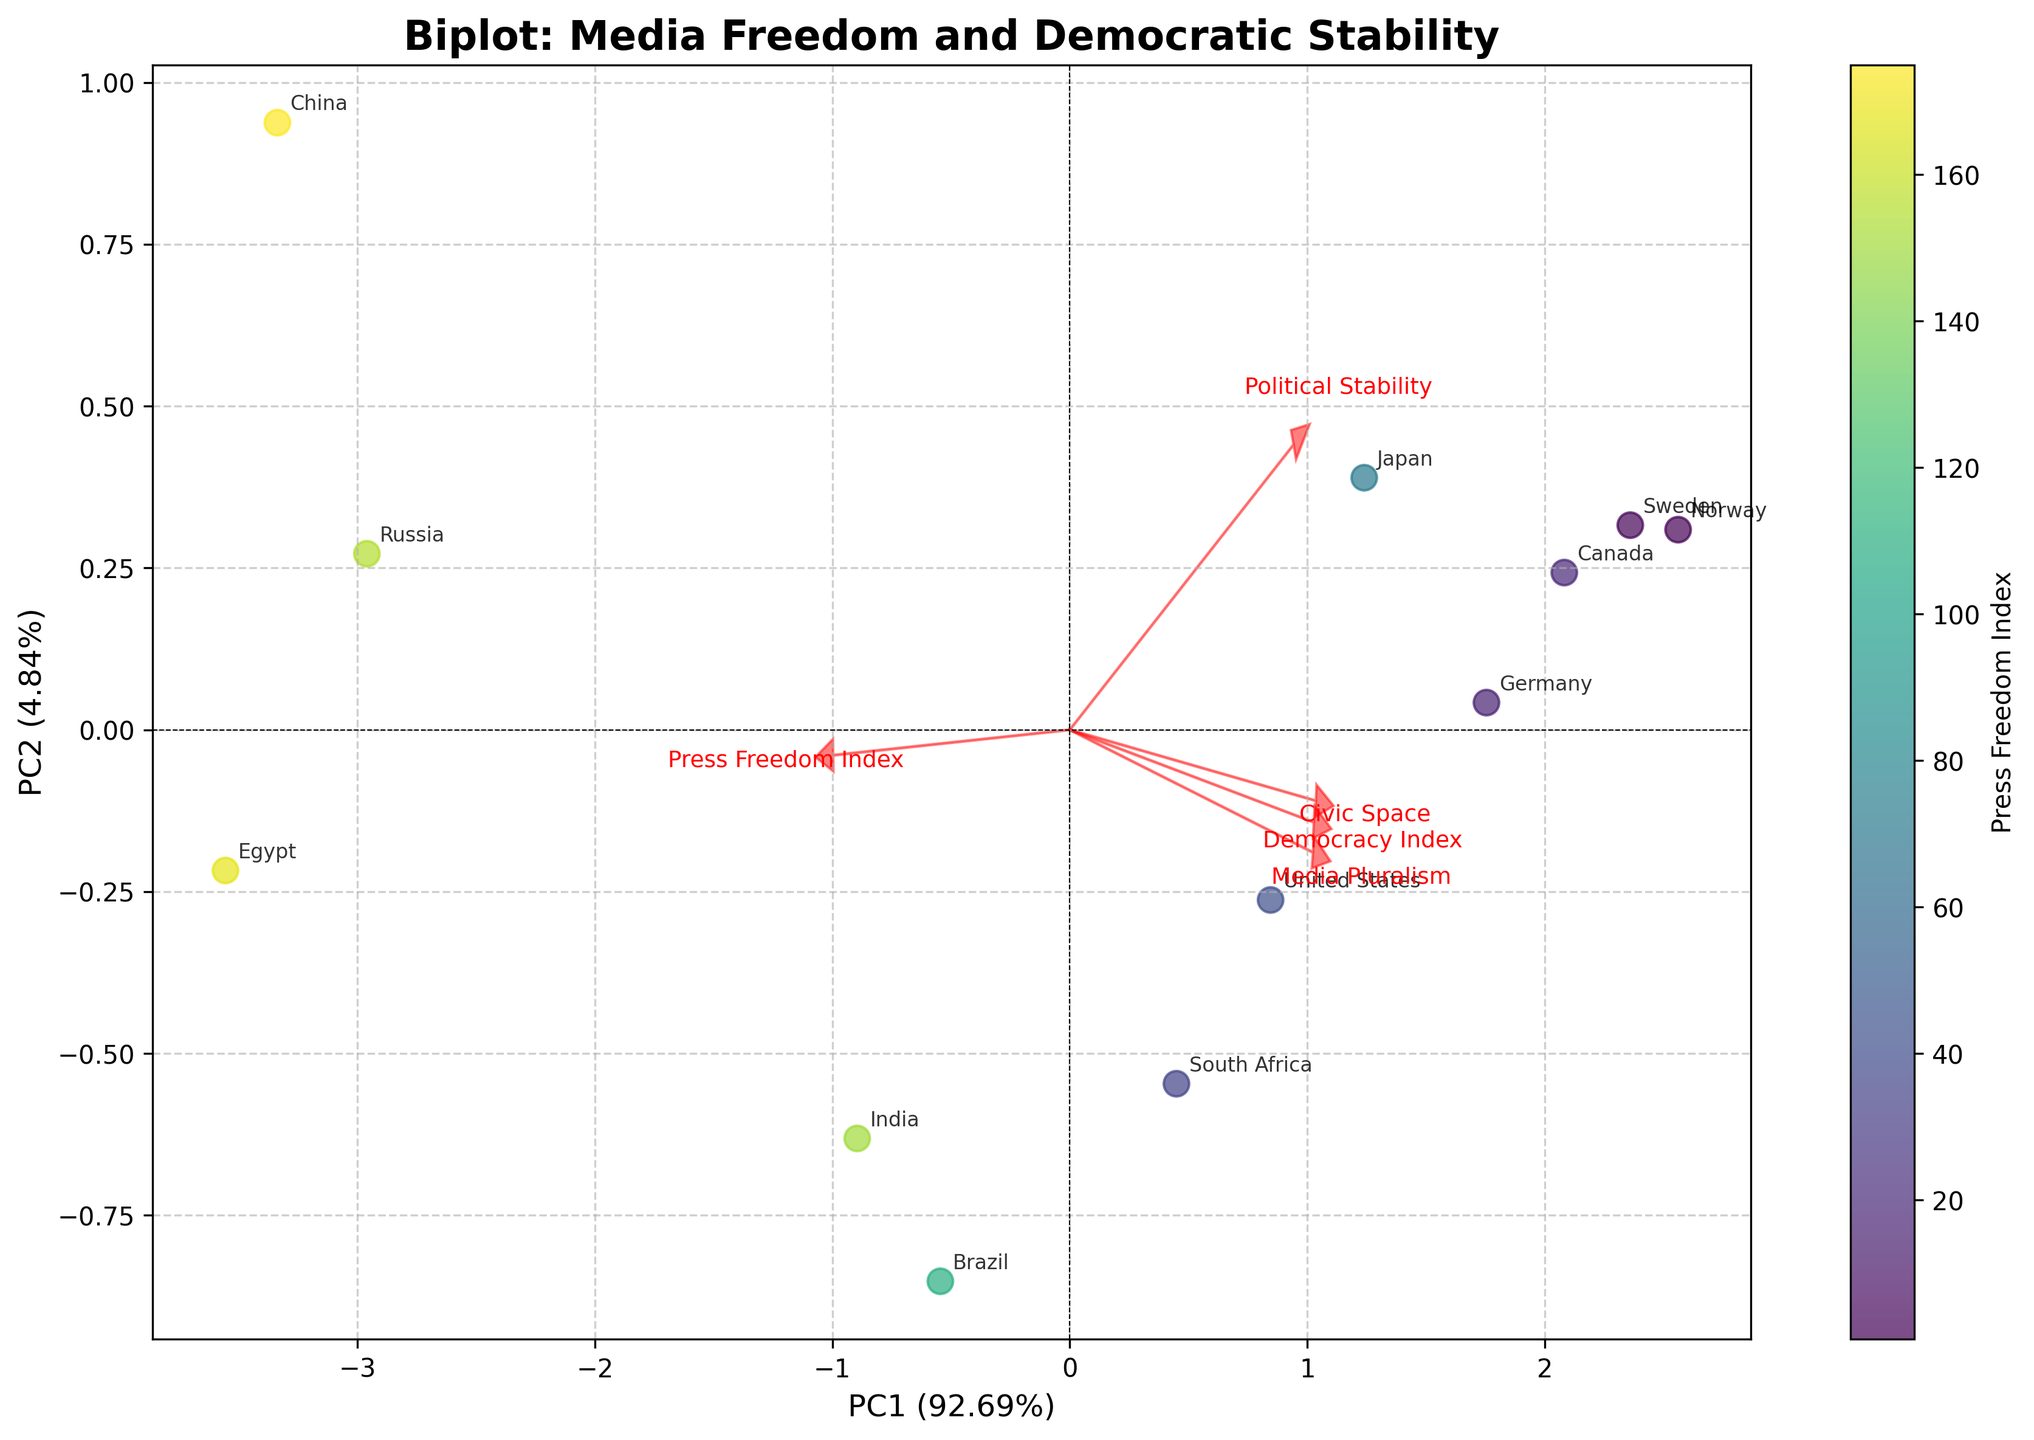What is the title of the figure? The title is written at the top of the figure. It reads "Biplot: Media Freedom and Democratic Stability."
Answer: Biplot: Media Freedom and Democratic Stability Which country has the lowest Press Freedom Index? To find the country with the lowest Press Freedom Index, look at the color bar and identify the darkest point. The darkest point corresponds to China.
Answer: China What are the axes labels of the figure? The axis labels are found next to the axes. The x-axis is labeled "PC1" and the y-axis is labeled "PC2," including the respective percentage of explained variance.
Answer: PC1 and PC2 Which country has the highest value for both Political Stability and Civic Space? Locate the arrow vectors for "Political Stability" and "Civic Space" and see which country is farthest in the direction of both arrows. Norway is positioned closest to the ends of these vectors.
Answer: Norway Compare the Democratic Index of the United States and China. Which one is higher? By checking the annotations, it's clear that the United States is positioned higher in the "Democracy Index" vector direction than China.
Answer: United States Which feature explains the most variance in PC1? Check the length of the loading vectors along PC1. The "Democracy Index" vector is the most extended along PC1.
Answer: Democracy Index Are there any countries with similar PC1 and PC2 values? Look for countries plotted very close together. Brazil and South Africa appear very close to each other on the plot, indicating similar PC1 and PC2 scores.
Answer: Brazil and South Africa What does the color in the scatter plot represent? The color gradient on the scatter plot is explained by the color bar title. It represents the "Press Freedom Index."
Answer: Press Freedom Index Which direction does the "Media Pluralism" vector point, and what does this indicate about the nations located in that direction? Observe the directional arrow for "Media Pluralism". It points toward the upper-right quadrant, indicating that countries like Canada and Norway have higher Media Pluralism scores.
Answer: Upper-right quadrant, Canada and Norway Which country is more stable, Germany or Russia, based on Political Stability? Look at the position of Germany and Russia in relation to the "Political Stability" vector. Germany is closer to the direction of the Political Stability arrow.
Answer: Germany 